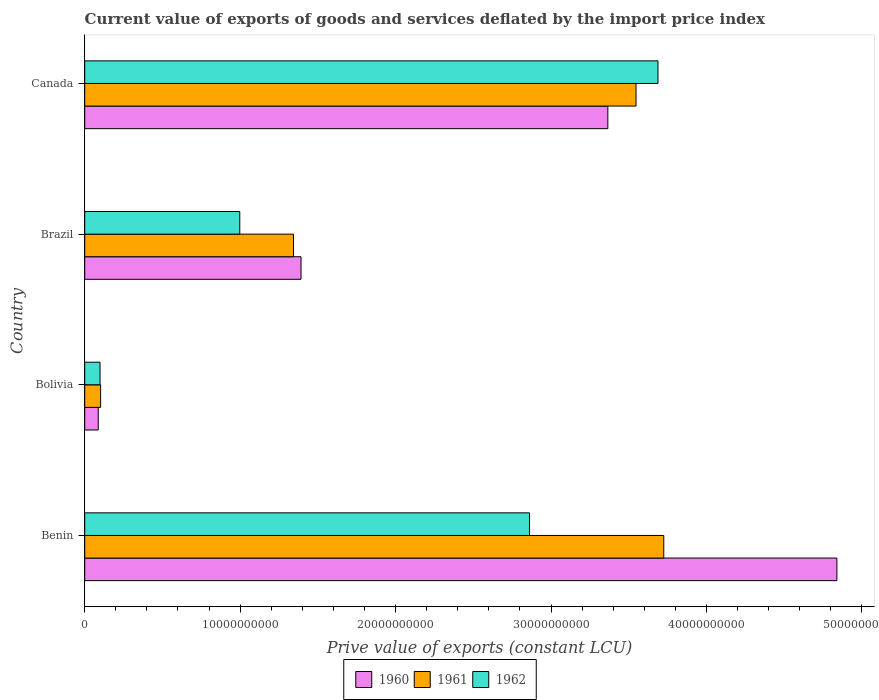Are the number of bars on each tick of the Y-axis equal?
Provide a short and direct response. Yes. How many bars are there on the 4th tick from the top?
Make the answer very short. 3. How many bars are there on the 2nd tick from the bottom?
Make the answer very short. 3. What is the label of the 4th group of bars from the top?
Your answer should be compact. Benin. What is the prive value of exports in 1961 in Canada?
Give a very brief answer. 3.55e+1. Across all countries, what is the maximum prive value of exports in 1960?
Your answer should be very brief. 4.84e+1. Across all countries, what is the minimum prive value of exports in 1961?
Offer a terse response. 1.02e+09. In which country was the prive value of exports in 1961 maximum?
Your response must be concise. Benin. What is the total prive value of exports in 1962 in the graph?
Provide a succinct answer. 7.65e+1. What is the difference between the prive value of exports in 1960 in Brazil and that in Canada?
Offer a very short reply. -1.97e+1. What is the difference between the prive value of exports in 1960 in Benin and the prive value of exports in 1961 in Brazil?
Offer a terse response. 3.50e+1. What is the average prive value of exports in 1960 per country?
Provide a succinct answer. 2.42e+1. What is the difference between the prive value of exports in 1960 and prive value of exports in 1961 in Brazil?
Ensure brevity in your answer.  4.85e+08. In how many countries, is the prive value of exports in 1960 greater than 38000000000 LCU?
Provide a succinct answer. 1. What is the ratio of the prive value of exports in 1962 in Bolivia to that in Brazil?
Ensure brevity in your answer.  0.1. What is the difference between the highest and the second highest prive value of exports in 1962?
Your answer should be compact. 8.26e+09. What is the difference between the highest and the lowest prive value of exports in 1960?
Your response must be concise. 4.75e+1. Is the sum of the prive value of exports in 1961 in Bolivia and Canada greater than the maximum prive value of exports in 1962 across all countries?
Offer a very short reply. No. What does the 1st bar from the top in Brazil represents?
Your answer should be compact. 1962. Is it the case that in every country, the sum of the prive value of exports in 1961 and prive value of exports in 1962 is greater than the prive value of exports in 1960?
Keep it short and to the point. Yes. How many bars are there?
Ensure brevity in your answer.  12. Are all the bars in the graph horizontal?
Offer a very short reply. Yes. How many countries are there in the graph?
Provide a succinct answer. 4. Does the graph contain grids?
Provide a succinct answer. No. Where does the legend appear in the graph?
Provide a short and direct response. Bottom center. How are the legend labels stacked?
Provide a succinct answer. Horizontal. What is the title of the graph?
Your answer should be very brief. Current value of exports of goods and services deflated by the import price index. Does "2014" appear as one of the legend labels in the graph?
Give a very brief answer. No. What is the label or title of the X-axis?
Your answer should be compact. Prive value of exports (constant LCU). What is the label or title of the Y-axis?
Keep it short and to the point. Country. What is the Prive value of exports (constant LCU) of 1960 in Benin?
Provide a short and direct response. 4.84e+1. What is the Prive value of exports (constant LCU) in 1961 in Benin?
Your answer should be very brief. 3.73e+1. What is the Prive value of exports (constant LCU) in 1962 in Benin?
Ensure brevity in your answer.  2.86e+1. What is the Prive value of exports (constant LCU) in 1960 in Bolivia?
Your response must be concise. 8.70e+08. What is the Prive value of exports (constant LCU) in 1961 in Bolivia?
Keep it short and to the point. 1.02e+09. What is the Prive value of exports (constant LCU) of 1962 in Bolivia?
Provide a short and direct response. 9.85e+08. What is the Prive value of exports (constant LCU) of 1960 in Brazil?
Ensure brevity in your answer.  1.39e+1. What is the Prive value of exports (constant LCU) of 1961 in Brazil?
Provide a short and direct response. 1.34e+1. What is the Prive value of exports (constant LCU) in 1962 in Brazil?
Keep it short and to the point. 9.97e+09. What is the Prive value of exports (constant LCU) of 1960 in Canada?
Provide a short and direct response. 3.37e+1. What is the Prive value of exports (constant LCU) of 1961 in Canada?
Your answer should be compact. 3.55e+1. What is the Prive value of exports (constant LCU) in 1962 in Canada?
Offer a terse response. 3.69e+1. Across all countries, what is the maximum Prive value of exports (constant LCU) in 1960?
Your answer should be compact. 4.84e+1. Across all countries, what is the maximum Prive value of exports (constant LCU) in 1961?
Offer a terse response. 3.73e+1. Across all countries, what is the maximum Prive value of exports (constant LCU) in 1962?
Your answer should be compact. 3.69e+1. Across all countries, what is the minimum Prive value of exports (constant LCU) of 1960?
Make the answer very short. 8.70e+08. Across all countries, what is the minimum Prive value of exports (constant LCU) of 1961?
Keep it short and to the point. 1.02e+09. Across all countries, what is the minimum Prive value of exports (constant LCU) of 1962?
Provide a succinct answer. 9.85e+08. What is the total Prive value of exports (constant LCU) of 1960 in the graph?
Make the answer very short. 9.68e+1. What is the total Prive value of exports (constant LCU) of 1961 in the graph?
Provide a short and direct response. 8.72e+1. What is the total Prive value of exports (constant LCU) of 1962 in the graph?
Provide a short and direct response. 7.65e+1. What is the difference between the Prive value of exports (constant LCU) in 1960 in Benin and that in Bolivia?
Offer a terse response. 4.75e+1. What is the difference between the Prive value of exports (constant LCU) of 1961 in Benin and that in Bolivia?
Your response must be concise. 3.62e+1. What is the difference between the Prive value of exports (constant LCU) in 1962 in Benin and that in Bolivia?
Your response must be concise. 2.76e+1. What is the difference between the Prive value of exports (constant LCU) of 1960 in Benin and that in Brazil?
Offer a terse response. 3.45e+1. What is the difference between the Prive value of exports (constant LCU) of 1961 in Benin and that in Brazil?
Make the answer very short. 2.38e+1. What is the difference between the Prive value of exports (constant LCU) of 1962 in Benin and that in Brazil?
Make the answer very short. 1.86e+1. What is the difference between the Prive value of exports (constant LCU) in 1960 in Benin and that in Canada?
Give a very brief answer. 1.47e+1. What is the difference between the Prive value of exports (constant LCU) of 1961 in Benin and that in Canada?
Offer a very short reply. 1.78e+09. What is the difference between the Prive value of exports (constant LCU) in 1962 in Benin and that in Canada?
Make the answer very short. -8.26e+09. What is the difference between the Prive value of exports (constant LCU) in 1960 in Bolivia and that in Brazil?
Your answer should be compact. -1.30e+1. What is the difference between the Prive value of exports (constant LCU) of 1961 in Bolivia and that in Brazil?
Offer a very short reply. -1.24e+1. What is the difference between the Prive value of exports (constant LCU) in 1962 in Bolivia and that in Brazil?
Provide a short and direct response. -8.99e+09. What is the difference between the Prive value of exports (constant LCU) of 1960 in Bolivia and that in Canada?
Ensure brevity in your answer.  -3.28e+1. What is the difference between the Prive value of exports (constant LCU) of 1961 in Bolivia and that in Canada?
Provide a short and direct response. -3.44e+1. What is the difference between the Prive value of exports (constant LCU) in 1962 in Bolivia and that in Canada?
Offer a very short reply. -3.59e+1. What is the difference between the Prive value of exports (constant LCU) in 1960 in Brazil and that in Canada?
Your answer should be very brief. -1.97e+1. What is the difference between the Prive value of exports (constant LCU) in 1961 in Brazil and that in Canada?
Provide a succinct answer. -2.20e+1. What is the difference between the Prive value of exports (constant LCU) in 1962 in Brazil and that in Canada?
Give a very brief answer. -2.69e+1. What is the difference between the Prive value of exports (constant LCU) in 1960 in Benin and the Prive value of exports (constant LCU) in 1961 in Bolivia?
Keep it short and to the point. 4.74e+1. What is the difference between the Prive value of exports (constant LCU) in 1960 in Benin and the Prive value of exports (constant LCU) in 1962 in Bolivia?
Keep it short and to the point. 4.74e+1. What is the difference between the Prive value of exports (constant LCU) of 1961 in Benin and the Prive value of exports (constant LCU) of 1962 in Bolivia?
Offer a very short reply. 3.63e+1. What is the difference between the Prive value of exports (constant LCU) in 1960 in Benin and the Prive value of exports (constant LCU) in 1961 in Brazil?
Make the answer very short. 3.50e+1. What is the difference between the Prive value of exports (constant LCU) of 1960 in Benin and the Prive value of exports (constant LCU) of 1962 in Brazil?
Your response must be concise. 3.84e+1. What is the difference between the Prive value of exports (constant LCU) in 1961 in Benin and the Prive value of exports (constant LCU) in 1962 in Brazil?
Give a very brief answer. 2.73e+1. What is the difference between the Prive value of exports (constant LCU) of 1960 in Benin and the Prive value of exports (constant LCU) of 1961 in Canada?
Provide a succinct answer. 1.29e+1. What is the difference between the Prive value of exports (constant LCU) of 1960 in Benin and the Prive value of exports (constant LCU) of 1962 in Canada?
Your answer should be very brief. 1.15e+1. What is the difference between the Prive value of exports (constant LCU) in 1961 in Benin and the Prive value of exports (constant LCU) in 1962 in Canada?
Offer a terse response. 3.72e+08. What is the difference between the Prive value of exports (constant LCU) in 1960 in Bolivia and the Prive value of exports (constant LCU) in 1961 in Brazil?
Ensure brevity in your answer.  -1.26e+1. What is the difference between the Prive value of exports (constant LCU) in 1960 in Bolivia and the Prive value of exports (constant LCU) in 1962 in Brazil?
Ensure brevity in your answer.  -9.10e+09. What is the difference between the Prive value of exports (constant LCU) of 1961 in Bolivia and the Prive value of exports (constant LCU) of 1962 in Brazil?
Keep it short and to the point. -8.95e+09. What is the difference between the Prive value of exports (constant LCU) in 1960 in Bolivia and the Prive value of exports (constant LCU) in 1961 in Canada?
Provide a short and direct response. -3.46e+1. What is the difference between the Prive value of exports (constant LCU) in 1960 in Bolivia and the Prive value of exports (constant LCU) in 1962 in Canada?
Your answer should be compact. -3.60e+1. What is the difference between the Prive value of exports (constant LCU) in 1961 in Bolivia and the Prive value of exports (constant LCU) in 1962 in Canada?
Provide a succinct answer. -3.59e+1. What is the difference between the Prive value of exports (constant LCU) of 1960 in Brazil and the Prive value of exports (constant LCU) of 1961 in Canada?
Your answer should be compact. -2.16e+1. What is the difference between the Prive value of exports (constant LCU) in 1960 in Brazil and the Prive value of exports (constant LCU) in 1962 in Canada?
Make the answer very short. -2.30e+1. What is the difference between the Prive value of exports (constant LCU) in 1961 in Brazil and the Prive value of exports (constant LCU) in 1962 in Canada?
Your answer should be very brief. -2.34e+1. What is the average Prive value of exports (constant LCU) in 1960 per country?
Give a very brief answer. 2.42e+1. What is the average Prive value of exports (constant LCU) of 1961 per country?
Make the answer very short. 2.18e+1. What is the average Prive value of exports (constant LCU) of 1962 per country?
Make the answer very short. 1.91e+1. What is the difference between the Prive value of exports (constant LCU) in 1960 and Prive value of exports (constant LCU) in 1961 in Benin?
Your answer should be compact. 1.11e+1. What is the difference between the Prive value of exports (constant LCU) in 1960 and Prive value of exports (constant LCU) in 1962 in Benin?
Your answer should be compact. 1.98e+1. What is the difference between the Prive value of exports (constant LCU) of 1961 and Prive value of exports (constant LCU) of 1962 in Benin?
Keep it short and to the point. 8.64e+09. What is the difference between the Prive value of exports (constant LCU) in 1960 and Prive value of exports (constant LCU) in 1961 in Bolivia?
Ensure brevity in your answer.  -1.53e+08. What is the difference between the Prive value of exports (constant LCU) in 1960 and Prive value of exports (constant LCU) in 1962 in Bolivia?
Keep it short and to the point. -1.15e+08. What is the difference between the Prive value of exports (constant LCU) in 1961 and Prive value of exports (constant LCU) in 1962 in Bolivia?
Make the answer very short. 3.86e+07. What is the difference between the Prive value of exports (constant LCU) of 1960 and Prive value of exports (constant LCU) of 1961 in Brazil?
Provide a short and direct response. 4.85e+08. What is the difference between the Prive value of exports (constant LCU) of 1960 and Prive value of exports (constant LCU) of 1962 in Brazil?
Make the answer very short. 3.94e+09. What is the difference between the Prive value of exports (constant LCU) of 1961 and Prive value of exports (constant LCU) of 1962 in Brazil?
Ensure brevity in your answer.  3.46e+09. What is the difference between the Prive value of exports (constant LCU) in 1960 and Prive value of exports (constant LCU) in 1961 in Canada?
Give a very brief answer. -1.81e+09. What is the difference between the Prive value of exports (constant LCU) of 1960 and Prive value of exports (constant LCU) of 1962 in Canada?
Your answer should be very brief. -3.23e+09. What is the difference between the Prive value of exports (constant LCU) in 1961 and Prive value of exports (constant LCU) in 1962 in Canada?
Make the answer very short. -1.41e+09. What is the ratio of the Prive value of exports (constant LCU) in 1960 in Benin to that in Bolivia?
Give a very brief answer. 55.59. What is the ratio of the Prive value of exports (constant LCU) in 1961 in Benin to that in Bolivia?
Your answer should be compact. 36.39. What is the ratio of the Prive value of exports (constant LCU) in 1962 in Benin to that in Bolivia?
Give a very brief answer. 29.05. What is the ratio of the Prive value of exports (constant LCU) in 1960 in Benin to that in Brazil?
Ensure brevity in your answer.  3.48. What is the ratio of the Prive value of exports (constant LCU) of 1961 in Benin to that in Brazil?
Keep it short and to the point. 2.77. What is the ratio of the Prive value of exports (constant LCU) of 1962 in Benin to that in Brazil?
Provide a short and direct response. 2.87. What is the ratio of the Prive value of exports (constant LCU) in 1960 in Benin to that in Canada?
Keep it short and to the point. 1.44. What is the ratio of the Prive value of exports (constant LCU) in 1961 in Benin to that in Canada?
Give a very brief answer. 1.05. What is the ratio of the Prive value of exports (constant LCU) of 1962 in Benin to that in Canada?
Your response must be concise. 0.78. What is the ratio of the Prive value of exports (constant LCU) in 1960 in Bolivia to that in Brazil?
Ensure brevity in your answer.  0.06. What is the ratio of the Prive value of exports (constant LCU) in 1961 in Bolivia to that in Brazil?
Offer a very short reply. 0.08. What is the ratio of the Prive value of exports (constant LCU) of 1962 in Bolivia to that in Brazil?
Ensure brevity in your answer.  0.1. What is the ratio of the Prive value of exports (constant LCU) in 1960 in Bolivia to that in Canada?
Your answer should be very brief. 0.03. What is the ratio of the Prive value of exports (constant LCU) in 1961 in Bolivia to that in Canada?
Keep it short and to the point. 0.03. What is the ratio of the Prive value of exports (constant LCU) in 1962 in Bolivia to that in Canada?
Your response must be concise. 0.03. What is the ratio of the Prive value of exports (constant LCU) of 1960 in Brazil to that in Canada?
Make the answer very short. 0.41. What is the ratio of the Prive value of exports (constant LCU) of 1961 in Brazil to that in Canada?
Provide a short and direct response. 0.38. What is the ratio of the Prive value of exports (constant LCU) in 1962 in Brazil to that in Canada?
Your answer should be compact. 0.27. What is the difference between the highest and the second highest Prive value of exports (constant LCU) in 1960?
Your answer should be compact. 1.47e+1. What is the difference between the highest and the second highest Prive value of exports (constant LCU) in 1961?
Offer a terse response. 1.78e+09. What is the difference between the highest and the second highest Prive value of exports (constant LCU) in 1962?
Ensure brevity in your answer.  8.26e+09. What is the difference between the highest and the lowest Prive value of exports (constant LCU) of 1960?
Make the answer very short. 4.75e+1. What is the difference between the highest and the lowest Prive value of exports (constant LCU) in 1961?
Your answer should be compact. 3.62e+1. What is the difference between the highest and the lowest Prive value of exports (constant LCU) in 1962?
Offer a terse response. 3.59e+1. 